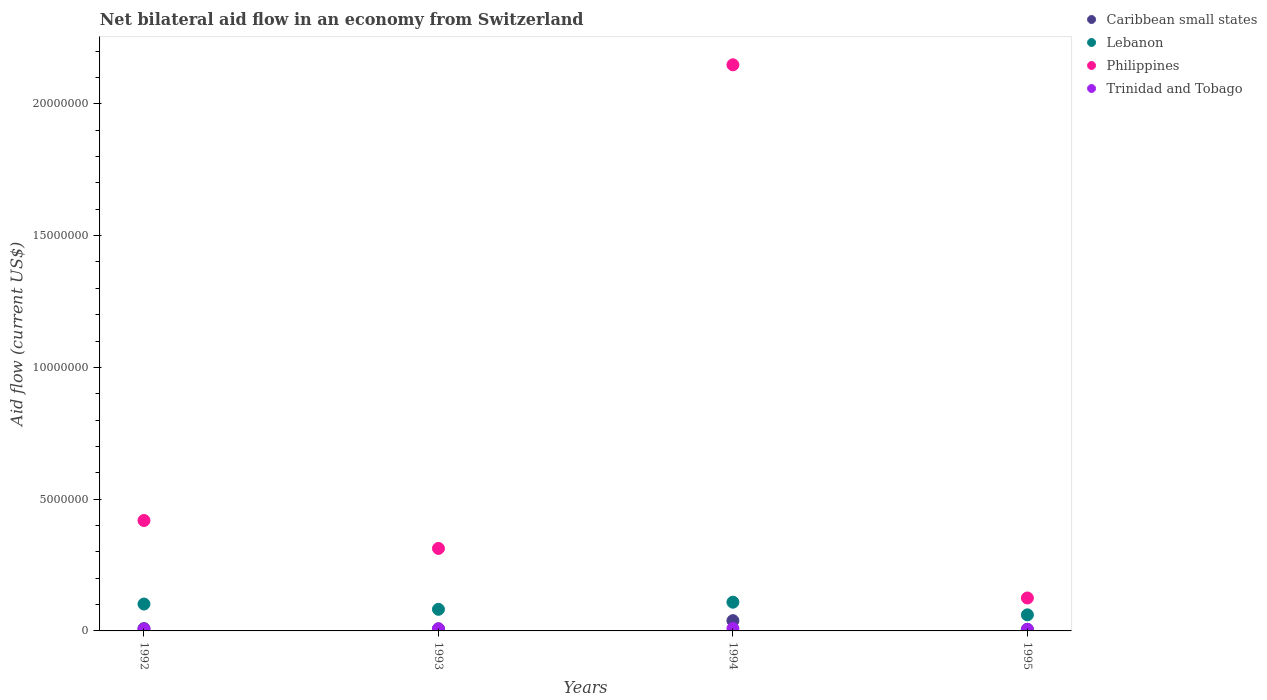How many different coloured dotlines are there?
Your answer should be very brief. 4. Is the number of dotlines equal to the number of legend labels?
Your response must be concise. Yes. What is the net bilateral aid flow in Philippines in 1993?
Give a very brief answer. 3.13e+06. Across all years, what is the minimum net bilateral aid flow in Trinidad and Tobago?
Make the answer very short. 6.00e+04. In which year was the net bilateral aid flow in Caribbean small states maximum?
Keep it short and to the point. 1994. In which year was the net bilateral aid flow in Caribbean small states minimum?
Offer a very short reply. 1995. What is the total net bilateral aid flow in Caribbean small states in the graph?
Provide a succinct answer. 6.20e+05. What is the difference between the net bilateral aid flow in Trinidad and Tobago in 1993 and the net bilateral aid flow in Caribbean small states in 1995?
Offer a terse response. 2.00e+04. What is the average net bilateral aid flow in Trinidad and Tobago per year?
Provide a short and direct response. 7.50e+04. In the year 1992, what is the difference between the net bilateral aid flow in Lebanon and net bilateral aid flow in Philippines?
Provide a succinct answer. -3.17e+06. What is the ratio of the net bilateral aid flow in Trinidad and Tobago in 1992 to that in 1995?
Offer a terse response. 1.17. Is the net bilateral aid flow in Trinidad and Tobago in 1993 less than that in 1994?
Offer a terse response. Yes. What is the difference between the highest and the second highest net bilateral aid flow in Lebanon?
Make the answer very short. 7.00e+04. What is the difference between the highest and the lowest net bilateral aid flow in Philippines?
Give a very brief answer. 2.02e+07. In how many years, is the net bilateral aid flow in Philippines greater than the average net bilateral aid flow in Philippines taken over all years?
Your answer should be very brief. 1. Is it the case that in every year, the sum of the net bilateral aid flow in Caribbean small states and net bilateral aid flow in Lebanon  is greater than the sum of net bilateral aid flow in Philippines and net bilateral aid flow in Trinidad and Tobago?
Give a very brief answer. No. Does the net bilateral aid flow in Philippines monotonically increase over the years?
Your answer should be very brief. No. Is the net bilateral aid flow in Lebanon strictly greater than the net bilateral aid flow in Philippines over the years?
Your answer should be compact. No. What is the difference between two consecutive major ticks on the Y-axis?
Your answer should be compact. 5.00e+06. Are the values on the major ticks of Y-axis written in scientific E-notation?
Offer a terse response. No. Where does the legend appear in the graph?
Offer a terse response. Top right. How many legend labels are there?
Keep it short and to the point. 4. How are the legend labels stacked?
Your answer should be compact. Vertical. What is the title of the graph?
Offer a terse response. Net bilateral aid flow in an economy from Switzerland. Does "High income: nonOECD" appear as one of the legend labels in the graph?
Ensure brevity in your answer.  No. What is the label or title of the Y-axis?
Provide a succinct answer. Aid flow (current US$). What is the Aid flow (current US$) in Caribbean small states in 1992?
Your answer should be very brief. 9.00e+04. What is the Aid flow (current US$) in Lebanon in 1992?
Provide a succinct answer. 1.02e+06. What is the Aid flow (current US$) in Philippines in 1992?
Your response must be concise. 4.19e+06. What is the Aid flow (current US$) of Trinidad and Tobago in 1992?
Give a very brief answer. 7.00e+04. What is the Aid flow (current US$) of Lebanon in 1993?
Your answer should be very brief. 8.20e+05. What is the Aid flow (current US$) of Philippines in 1993?
Offer a terse response. 3.13e+06. What is the Aid flow (current US$) in Lebanon in 1994?
Offer a terse response. 1.09e+06. What is the Aid flow (current US$) in Philippines in 1994?
Offer a terse response. 2.15e+07. What is the Aid flow (current US$) in Trinidad and Tobago in 1994?
Ensure brevity in your answer.  9.00e+04. What is the Aid flow (current US$) in Caribbean small states in 1995?
Keep it short and to the point. 6.00e+04. What is the Aid flow (current US$) in Lebanon in 1995?
Offer a very short reply. 6.10e+05. What is the Aid flow (current US$) of Philippines in 1995?
Provide a short and direct response. 1.25e+06. What is the Aid flow (current US$) in Trinidad and Tobago in 1995?
Your response must be concise. 6.00e+04. Across all years, what is the maximum Aid flow (current US$) of Caribbean small states?
Your answer should be very brief. 3.90e+05. Across all years, what is the maximum Aid flow (current US$) of Lebanon?
Your answer should be compact. 1.09e+06. Across all years, what is the maximum Aid flow (current US$) in Philippines?
Offer a terse response. 2.15e+07. Across all years, what is the maximum Aid flow (current US$) of Trinidad and Tobago?
Your answer should be very brief. 9.00e+04. Across all years, what is the minimum Aid flow (current US$) in Caribbean small states?
Provide a succinct answer. 6.00e+04. Across all years, what is the minimum Aid flow (current US$) in Philippines?
Your answer should be compact. 1.25e+06. Across all years, what is the minimum Aid flow (current US$) of Trinidad and Tobago?
Offer a very short reply. 6.00e+04. What is the total Aid flow (current US$) in Caribbean small states in the graph?
Give a very brief answer. 6.20e+05. What is the total Aid flow (current US$) of Lebanon in the graph?
Make the answer very short. 3.54e+06. What is the total Aid flow (current US$) in Philippines in the graph?
Provide a short and direct response. 3.00e+07. What is the total Aid flow (current US$) in Trinidad and Tobago in the graph?
Keep it short and to the point. 3.00e+05. What is the difference between the Aid flow (current US$) in Philippines in 1992 and that in 1993?
Make the answer very short. 1.06e+06. What is the difference between the Aid flow (current US$) of Trinidad and Tobago in 1992 and that in 1993?
Give a very brief answer. -10000. What is the difference between the Aid flow (current US$) in Caribbean small states in 1992 and that in 1994?
Your answer should be compact. -3.00e+05. What is the difference between the Aid flow (current US$) in Lebanon in 1992 and that in 1994?
Provide a short and direct response. -7.00e+04. What is the difference between the Aid flow (current US$) in Philippines in 1992 and that in 1994?
Your answer should be compact. -1.73e+07. What is the difference between the Aid flow (current US$) in Trinidad and Tobago in 1992 and that in 1994?
Your answer should be compact. -2.00e+04. What is the difference between the Aid flow (current US$) of Caribbean small states in 1992 and that in 1995?
Provide a succinct answer. 3.00e+04. What is the difference between the Aid flow (current US$) in Philippines in 1992 and that in 1995?
Offer a terse response. 2.94e+06. What is the difference between the Aid flow (current US$) in Caribbean small states in 1993 and that in 1994?
Your response must be concise. -3.10e+05. What is the difference between the Aid flow (current US$) of Philippines in 1993 and that in 1994?
Provide a short and direct response. -1.84e+07. What is the difference between the Aid flow (current US$) of Philippines in 1993 and that in 1995?
Your answer should be very brief. 1.88e+06. What is the difference between the Aid flow (current US$) in Trinidad and Tobago in 1993 and that in 1995?
Make the answer very short. 2.00e+04. What is the difference between the Aid flow (current US$) in Caribbean small states in 1994 and that in 1995?
Make the answer very short. 3.30e+05. What is the difference between the Aid flow (current US$) of Lebanon in 1994 and that in 1995?
Your answer should be compact. 4.80e+05. What is the difference between the Aid flow (current US$) of Philippines in 1994 and that in 1995?
Your response must be concise. 2.02e+07. What is the difference between the Aid flow (current US$) in Caribbean small states in 1992 and the Aid flow (current US$) in Lebanon in 1993?
Your answer should be very brief. -7.30e+05. What is the difference between the Aid flow (current US$) of Caribbean small states in 1992 and the Aid flow (current US$) of Philippines in 1993?
Your response must be concise. -3.04e+06. What is the difference between the Aid flow (current US$) of Caribbean small states in 1992 and the Aid flow (current US$) of Trinidad and Tobago in 1993?
Provide a succinct answer. 10000. What is the difference between the Aid flow (current US$) of Lebanon in 1992 and the Aid flow (current US$) of Philippines in 1993?
Ensure brevity in your answer.  -2.11e+06. What is the difference between the Aid flow (current US$) of Lebanon in 1992 and the Aid flow (current US$) of Trinidad and Tobago in 1993?
Provide a short and direct response. 9.40e+05. What is the difference between the Aid flow (current US$) in Philippines in 1992 and the Aid flow (current US$) in Trinidad and Tobago in 1993?
Make the answer very short. 4.11e+06. What is the difference between the Aid flow (current US$) in Caribbean small states in 1992 and the Aid flow (current US$) in Philippines in 1994?
Your answer should be compact. -2.14e+07. What is the difference between the Aid flow (current US$) in Caribbean small states in 1992 and the Aid flow (current US$) in Trinidad and Tobago in 1994?
Offer a very short reply. 0. What is the difference between the Aid flow (current US$) in Lebanon in 1992 and the Aid flow (current US$) in Philippines in 1994?
Offer a terse response. -2.05e+07. What is the difference between the Aid flow (current US$) of Lebanon in 1992 and the Aid flow (current US$) of Trinidad and Tobago in 1994?
Your response must be concise. 9.30e+05. What is the difference between the Aid flow (current US$) in Philippines in 1992 and the Aid flow (current US$) in Trinidad and Tobago in 1994?
Make the answer very short. 4.10e+06. What is the difference between the Aid flow (current US$) in Caribbean small states in 1992 and the Aid flow (current US$) in Lebanon in 1995?
Your response must be concise. -5.20e+05. What is the difference between the Aid flow (current US$) in Caribbean small states in 1992 and the Aid flow (current US$) in Philippines in 1995?
Your response must be concise. -1.16e+06. What is the difference between the Aid flow (current US$) of Lebanon in 1992 and the Aid flow (current US$) of Philippines in 1995?
Make the answer very short. -2.30e+05. What is the difference between the Aid flow (current US$) in Lebanon in 1992 and the Aid flow (current US$) in Trinidad and Tobago in 1995?
Ensure brevity in your answer.  9.60e+05. What is the difference between the Aid flow (current US$) in Philippines in 1992 and the Aid flow (current US$) in Trinidad and Tobago in 1995?
Keep it short and to the point. 4.13e+06. What is the difference between the Aid flow (current US$) in Caribbean small states in 1993 and the Aid flow (current US$) in Lebanon in 1994?
Keep it short and to the point. -1.01e+06. What is the difference between the Aid flow (current US$) of Caribbean small states in 1993 and the Aid flow (current US$) of Philippines in 1994?
Give a very brief answer. -2.14e+07. What is the difference between the Aid flow (current US$) of Caribbean small states in 1993 and the Aid flow (current US$) of Trinidad and Tobago in 1994?
Provide a succinct answer. -10000. What is the difference between the Aid flow (current US$) of Lebanon in 1993 and the Aid flow (current US$) of Philippines in 1994?
Your response must be concise. -2.07e+07. What is the difference between the Aid flow (current US$) of Lebanon in 1993 and the Aid flow (current US$) of Trinidad and Tobago in 1994?
Offer a terse response. 7.30e+05. What is the difference between the Aid flow (current US$) of Philippines in 1993 and the Aid flow (current US$) of Trinidad and Tobago in 1994?
Offer a terse response. 3.04e+06. What is the difference between the Aid flow (current US$) of Caribbean small states in 1993 and the Aid flow (current US$) of Lebanon in 1995?
Your response must be concise. -5.30e+05. What is the difference between the Aid flow (current US$) of Caribbean small states in 1993 and the Aid flow (current US$) of Philippines in 1995?
Keep it short and to the point. -1.17e+06. What is the difference between the Aid flow (current US$) in Caribbean small states in 1993 and the Aid flow (current US$) in Trinidad and Tobago in 1995?
Keep it short and to the point. 2.00e+04. What is the difference between the Aid flow (current US$) in Lebanon in 1993 and the Aid flow (current US$) in Philippines in 1995?
Keep it short and to the point. -4.30e+05. What is the difference between the Aid flow (current US$) in Lebanon in 1993 and the Aid flow (current US$) in Trinidad and Tobago in 1995?
Provide a succinct answer. 7.60e+05. What is the difference between the Aid flow (current US$) in Philippines in 1993 and the Aid flow (current US$) in Trinidad and Tobago in 1995?
Provide a short and direct response. 3.07e+06. What is the difference between the Aid flow (current US$) of Caribbean small states in 1994 and the Aid flow (current US$) of Philippines in 1995?
Give a very brief answer. -8.60e+05. What is the difference between the Aid flow (current US$) in Lebanon in 1994 and the Aid flow (current US$) in Philippines in 1995?
Ensure brevity in your answer.  -1.60e+05. What is the difference between the Aid flow (current US$) in Lebanon in 1994 and the Aid flow (current US$) in Trinidad and Tobago in 1995?
Provide a short and direct response. 1.03e+06. What is the difference between the Aid flow (current US$) in Philippines in 1994 and the Aid flow (current US$) in Trinidad and Tobago in 1995?
Keep it short and to the point. 2.14e+07. What is the average Aid flow (current US$) of Caribbean small states per year?
Provide a succinct answer. 1.55e+05. What is the average Aid flow (current US$) in Lebanon per year?
Provide a succinct answer. 8.85e+05. What is the average Aid flow (current US$) of Philippines per year?
Your answer should be very brief. 7.51e+06. What is the average Aid flow (current US$) of Trinidad and Tobago per year?
Ensure brevity in your answer.  7.50e+04. In the year 1992, what is the difference between the Aid flow (current US$) in Caribbean small states and Aid flow (current US$) in Lebanon?
Provide a short and direct response. -9.30e+05. In the year 1992, what is the difference between the Aid flow (current US$) in Caribbean small states and Aid flow (current US$) in Philippines?
Your answer should be very brief. -4.10e+06. In the year 1992, what is the difference between the Aid flow (current US$) of Lebanon and Aid flow (current US$) of Philippines?
Make the answer very short. -3.17e+06. In the year 1992, what is the difference between the Aid flow (current US$) in Lebanon and Aid flow (current US$) in Trinidad and Tobago?
Your response must be concise. 9.50e+05. In the year 1992, what is the difference between the Aid flow (current US$) in Philippines and Aid flow (current US$) in Trinidad and Tobago?
Ensure brevity in your answer.  4.12e+06. In the year 1993, what is the difference between the Aid flow (current US$) in Caribbean small states and Aid flow (current US$) in Lebanon?
Offer a terse response. -7.40e+05. In the year 1993, what is the difference between the Aid flow (current US$) in Caribbean small states and Aid flow (current US$) in Philippines?
Keep it short and to the point. -3.05e+06. In the year 1993, what is the difference between the Aid flow (current US$) in Lebanon and Aid flow (current US$) in Philippines?
Make the answer very short. -2.31e+06. In the year 1993, what is the difference between the Aid flow (current US$) of Lebanon and Aid flow (current US$) of Trinidad and Tobago?
Your answer should be very brief. 7.40e+05. In the year 1993, what is the difference between the Aid flow (current US$) in Philippines and Aid flow (current US$) in Trinidad and Tobago?
Provide a short and direct response. 3.05e+06. In the year 1994, what is the difference between the Aid flow (current US$) of Caribbean small states and Aid flow (current US$) of Lebanon?
Your answer should be very brief. -7.00e+05. In the year 1994, what is the difference between the Aid flow (current US$) in Caribbean small states and Aid flow (current US$) in Philippines?
Provide a succinct answer. -2.11e+07. In the year 1994, what is the difference between the Aid flow (current US$) in Caribbean small states and Aid flow (current US$) in Trinidad and Tobago?
Offer a very short reply. 3.00e+05. In the year 1994, what is the difference between the Aid flow (current US$) of Lebanon and Aid flow (current US$) of Philippines?
Provide a succinct answer. -2.04e+07. In the year 1994, what is the difference between the Aid flow (current US$) of Lebanon and Aid flow (current US$) of Trinidad and Tobago?
Offer a very short reply. 1.00e+06. In the year 1994, what is the difference between the Aid flow (current US$) in Philippines and Aid flow (current US$) in Trinidad and Tobago?
Offer a terse response. 2.14e+07. In the year 1995, what is the difference between the Aid flow (current US$) of Caribbean small states and Aid flow (current US$) of Lebanon?
Make the answer very short. -5.50e+05. In the year 1995, what is the difference between the Aid flow (current US$) in Caribbean small states and Aid flow (current US$) in Philippines?
Ensure brevity in your answer.  -1.19e+06. In the year 1995, what is the difference between the Aid flow (current US$) in Lebanon and Aid flow (current US$) in Philippines?
Your answer should be compact. -6.40e+05. In the year 1995, what is the difference between the Aid flow (current US$) of Lebanon and Aid flow (current US$) of Trinidad and Tobago?
Provide a short and direct response. 5.50e+05. In the year 1995, what is the difference between the Aid flow (current US$) of Philippines and Aid flow (current US$) of Trinidad and Tobago?
Offer a terse response. 1.19e+06. What is the ratio of the Aid flow (current US$) of Caribbean small states in 1992 to that in 1993?
Your answer should be very brief. 1.12. What is the ratio of the Aid flow (current US$) in Lebanon in 1992 to that in 1993?
Make the answer very short. 1.24. What is the ratio of the Aid flow (current US$) in Philippines in 1992 to that in 1993?
Your answer should be very brief. 1.34. What is the ratio of the Aid flow (current US$) of Caribbean small states in 1992 to that in 1994?
Your answer should be compact. 0.23. What is the ratio of the Aid flow (current US$) in Lebanon in 1992 to that in 1994?
Give a very brief answer. 0.94. What is the ratio of the Aid flow (current US$) of Philippines in 1992 to that in 1994?
Make the answer very short. 0.2. What is the ratio of the Aid flow (current US$) in Trinidad and Tobago in 1992 to that in 1994?
Provide a succinct answer. 0.78. What is the ratio of the Aid flow (current US$) in Caribbean small states in 1992 to that in 1995?
Provide a short and direct response. 1.5. What is the ratio of the Aid flow (current US$) in Lebanon in 1992 to that in 1995?
Provide a succinct answer. 1.67. What is the ratio of the Aid flow (current US$) in Philippines in 1992 to that in 1995?
Offer a terse response. 3.35. What is the ratio of the Aid flow (current US$) of Caribbean small states in 1993 to that in 1994?
Your answer should be compact. 0.21. What is the ratio of the Aid flow (current US$) of Lebanon in 1993 to that in 1994?
Provide a succinct answer. 0.75. What is the ratio of the Aid flow (current US$) in Philippines in 1993 to that in 1994?
Keep it short and to the point. 0.15. What is the ratio of the Aid flow (current US$) of Trinidad and Tobago in 1993 to that in 1994?
Offer a terse response. 0.89. What is the ratio of the Aid flow (current US$) in Lebanon in 1993 to that in 1995?
Make the answer very short. 1.34. What is the ratio of the Aid flow (current US$) in Philippines in 1993 to that in 1995?
Offer a very short reply. 2.5. What is the ratio of the Aid flow (current US$) of Caribbean small states in 1994 to that in 1995?
Your response must be concise. 6.5. What is the ratio of the Aid flow (current US$) of Lebanon in 1994 to that in 1995?
Provide a short and direct response. 1.79. What is the ratio of the Aid flow (current US$) in Philippines in 1994 to that in 1995?
Ensure brevity in your answer.  17.18. What is the ratio of the Aid flow (current US$) of Trinidad and Tobago in 1994 to that in 1995?
Provide a succinct answer. 1.5. What is the difference between the highest and the second highest Aid flow (current US$) of Philippines?
Your response must be concise. 1.73e+07. What is the difference between the highest and the second highest Aid flow (current US$) in Trinidad and Tobago?
Give a very brief answer. 10000. What is the difference between the highest and the lowest Aid flow (current US$) in Lebanon?
Offer a terse response. 4.80e+05. What is the difference between the highest and the lowest Aid flow (current US$) in Philippines?
Give a very brief answer. 2.02e+07. 